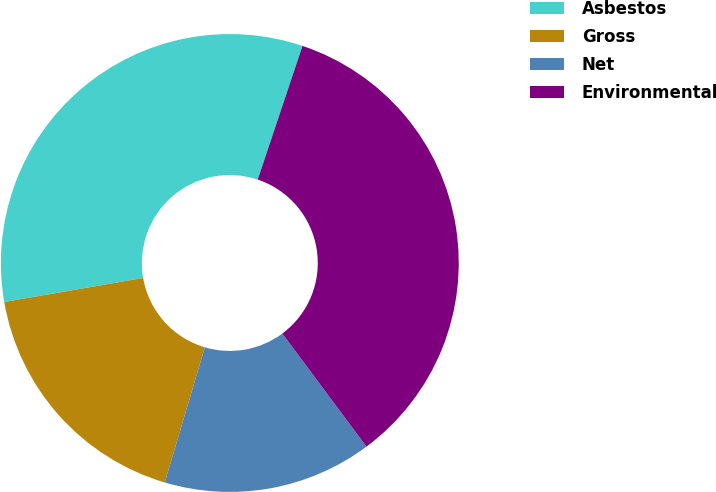Convert chart. <chart><loc_0><loc_0><loc_500><loc_500><pie_chart><fcel>Asbestos<fcel>Gross<fcel>Net<fcel>Environmental<nl><fcel>32.87%<fcel>17.69%<fcel>14.77%<fcel>34.68%<nl></chart> 